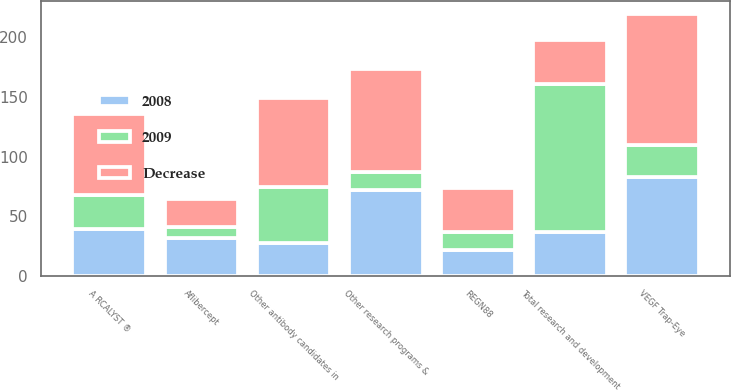<chart> <loc_0><loc_0><loc_500><loc_500><stacked_bar_chart><ecel><fcel>A RCALYST ®<fcel>VEGF Trap-Eye<fcel>Aflibercept<fcel>REGN88<fcel>Other antibody candidates in<fcel>Other research programs &<fcel>Total research and development<nl><fcel>Decrease<fcel>67.7<fcel>109.8<fcel>23.3<fcel>36.9<fcel>74.4<fcel>86.7<fcel>36.9<nl><fcel>2008<fcel>39.2<fcel>82.7<fcel>32.1<fcel>21.4<fcel>27.4<fcel>72.1<fcel>36.9<nl><fcel>2009<fcel>28.5<fcel>27.1<fcel>8.8<fcel>15.5<fcel>47<fcel>14.6<fcel>123.9<nl></chart> 